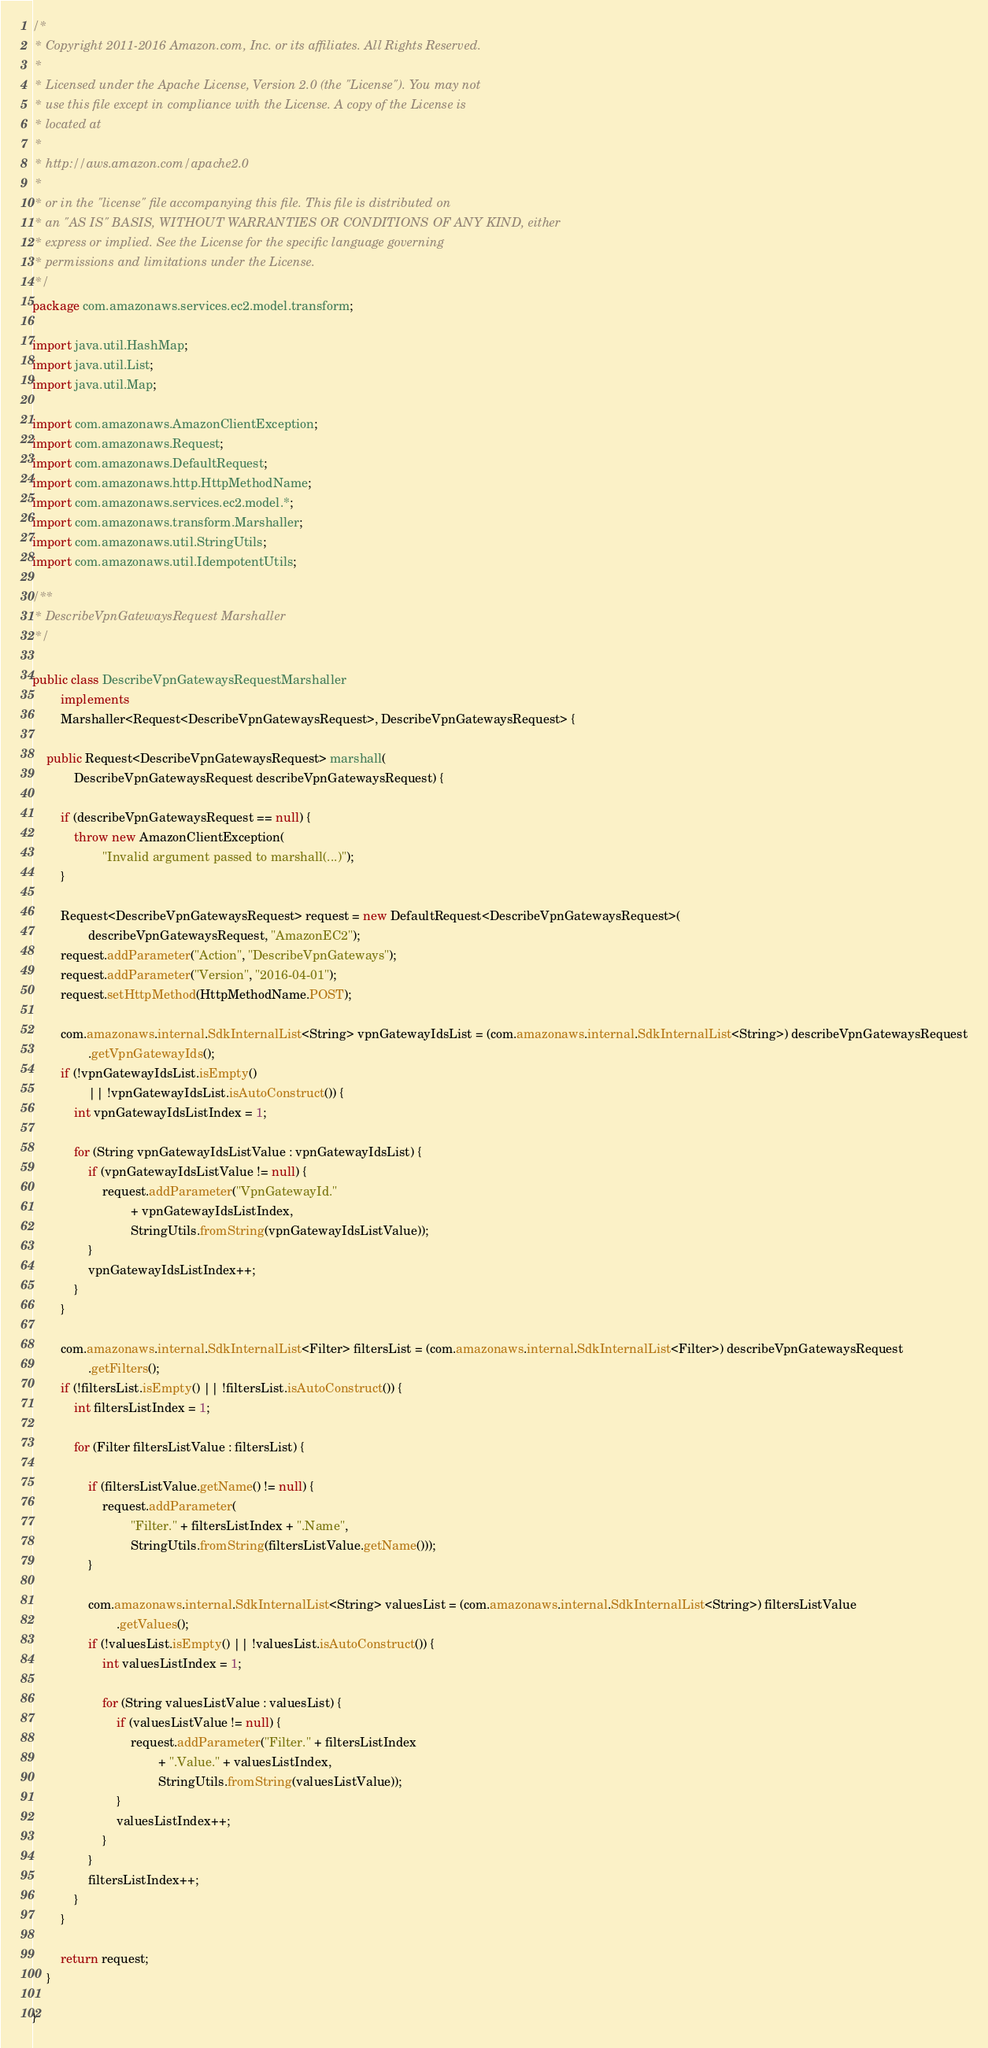Convert code to text. <code><loc_0><loc_0><loc_500><loc_500><_Java_>/*
 * Copyright 2011-2016 Amazon.com, Inc. or its affiliates. All Rights Reserved.
 * 
 * Licensed under the Apache License, Version 2.0 (the "License"). You may not
 * use this file except in compliance with the License. A copy of the License is
 * located at
 * 
 * http://aws.amazon.com/apache2.0
 * 
 * or in the "license" file accompanying this file. This file is distributed on
 * an "AS IS" BASIS, WITHOUT WARRANTIES OR CONDITIONS OF ANY KIND, either
 * express or implied. See the License for the specific language governing
 * permissions and limitations under the License.
 */
package com.amazonaws.services.ec2.model.transform;

import java.util.HashMap;
import java.util.List;
import java.util.Map;

import com.amazonaws.AmazonClientException;
import com.amazonaws.Request;
import com.amazonaws.DefaultRequest;
import com.amazonaws.http.HttpMethodName;
import com.amazonaws.services.ec2.model.*;
import com.amazonaws.transform.Marshaller;
import com.amazonaws.util.StringUtils;
import com.amazonaws.util.IdempotentUtils;

/**
 * DescribeVpnGatewaysRequest Marshaller
 */

public class DescribeVpnGatewaysRequestMarshaller
        implements
        Marshaller<Request<DescribeVpnGatewaysRequest>, DescribeVpnGatewaysRequest> {

    public Request<DescribeVpnGatewaysRequest> marshall(
            DescribeVpnGatewaysRequest describeVpnGatewaysRequest) {

        if (describeVpnGatewaysRequest == null) {
            throw new AmazonClientException(
                    "Invalid argument passed to marshall(...)");
        }

        Request<DescribeVpnGatewaysRequest> request = new DefaultRequest<DescribeVpnGatewaysRequest>(
                describeVpnGatewaysRequest, "AmazonEC2");
        request.addParameter("Action", "DescribeVpnGateways");
        request.addParameter("Version", "2016-04-01");
        request.setHttpMethod(HttpMethodName.POST);

        com.amazonaws.internal.SdkInternalList<String> vpnGatewayIdsList = (com.amazonaws.internal.SdkInternalList<String>) describeVpnGatewaysRequest
                .getVpnGatewayIds();
        if (!vpnGatewayIdsList.isEmpty()
                || !vpnGatewayIdsList.isAutoConstruct()) {
            int vpnGatewayIdsListIndex = 1;

            for (String vpnGatewayIdsListValue : vpnGatewayIdsList) {
                if (vpnGatewayIdsListValue != null) {
                    request.addParameter("VpnGatewayId."
                            + vpnGatewayIdsListIndex,
                            StringUtils.fromString(vpnGatewayIdsListValue));
                }
                vpnGatewayIdsListIndex++;
            }
        }

        com.amazonaws.internal.SdkInternalList<Filter> filtersList = (com.amazonaws.internal.SdkInternalList<Filter>) describeVpnGatewaysRequest
                .getFilters();
        if (!filtersList.isEmpty() || !filtersList.isAutoConstruct()) {
            int filtersListIndex = 1;

            for (Filter filtersListValue : filtersList) {

                if (filtersListValue.getName() != null) {
                    request.addParameter(
                            "Filter." + filtersListIndex + ".Name",
                            StringUtils.fromString(filtersListValue.getName()));
                }

                com.amazonaws.internal.SdkInternalList<String> valuesList = (com.amazonaws.internal.SdkInternalList<String>) filtersListValue
                        .getValues();
                if (!valuesList.isEmpty() || !valuesList.isAutoConstruct()) {
                    int valuesListIndex = 1;

                    for (String valuesListValue : valuesList) {
                        if (valuesListValue != null) {
                            request.addParameter("Filter." + filtersListIndex
                                    + ".Value." + valuesListIndex,
                                    StringUtils.fromString(valuesListValue));
                        }
                        valuesListIndex++;
                    }
                }
                filtersListIndex++;
            }
        }

        return request;
    }

}
</code> 